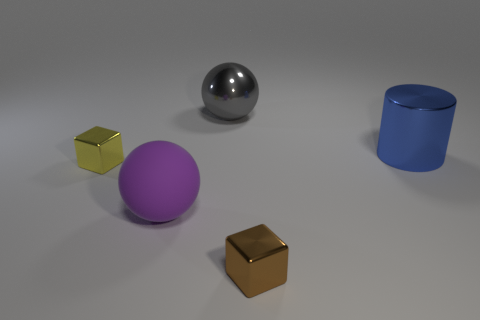Is there any other thing that has the same material as the purple thing?
Make the answer very short. No. Are the cube that is on the left side of the metallic sphere and the brown block made of the same material?
Give a very brief answer. Yes. There is a small metal object to the right of the ball in front of the shiny block that is behind the small brown metallic cube; what shape is it?
Your answer should be compact. Cube. What number of cyan things are either shiny things or big metallic cylinders?
Your response must be concise. 0. Are there an equal number of large gray balls on the left side of the large gray sphere and large purple matte objects behind the big purple sphere?
Your answer should be very brief. Yes. Does the tiny thing that is in front of the big purple thing have the same shape as the large thing behind the blue cylinder?
Keep it short and to the point. No. Is there any other thing that has the same shape as the blue shiny object?
Provide a succinct answer. No. What shape is the big blue object that is the same material as the small brown cube?
Offer a terse response. Cylinder. Are there the same number of big gray metallic spheres that are in front of the blue metal object and big cyan spheres?
Provide a short and direct response. Yes. Is the material of the big object to the right of the gray metal thing the same as the small object that is to the left of the brown metallic object?
Keep it short and to the point. Yes. 